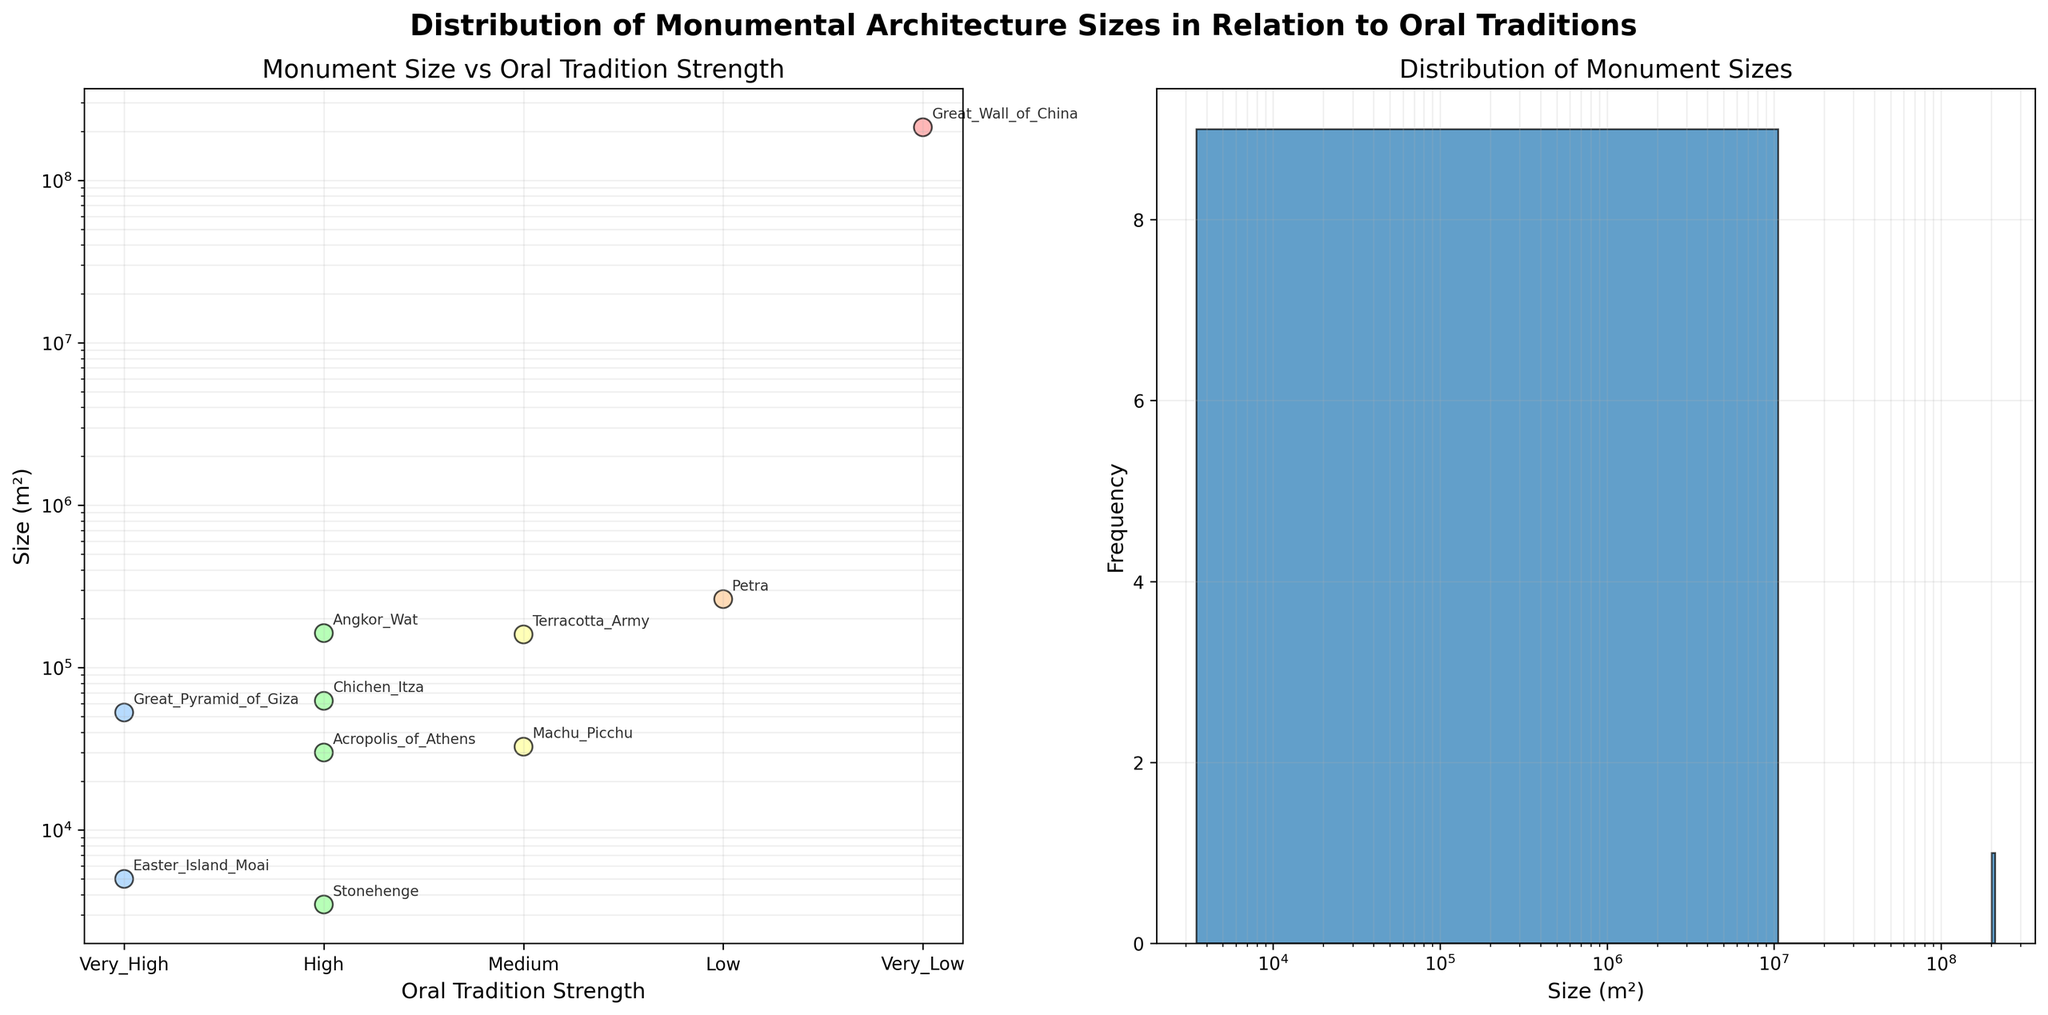Which monumental architecture has the highest size? To determine this, look at the scatter plot or the distribution histogram to identify the tallest data point on the Size axis (log scale). The highest value corresponds to the "Great Wall of China" at approximately 211,960,000 m².
Answer: Great Wall of China How many architectures are there with a 'High' oral tradition strength? In the scatter plot, observe the points colored similarly and labeled 'High'. Count these points: Stonehenge, Angkor Wat, Chichen Itza, and Acropolis of Athens, totaling 4.
Answer: 4 Which visualization shows the frequency of monument sizes? The subplot on the right shows a histogram displaying the frequency distribution of the size of monuments.
Answer: Histogram (right subplot) How does the size of Petra compare to Machu Picchu? In the scatter plot, find Petra and Machu Picchu and compare their positions on the y-axis. Petra is larger with 264,000 m², whereas Machu Picchu is 32,580 m².
Answer: Petra is larger What is the size difference between the largest and smallest monuments? Compare the Great Wall of China's size (211,960,000 m²) with Stonehenge's (3,480 m²). Calculate the difference: 211,960,000 - 3,480 = 211,956,520 m².
Answer: 211,956,520 m² Which oral tradition strength category contains the smallest monument? Look at the scatter plot, identify the monument with the smallest size, and note its corresponding oral tradition strength. Stonehenge (3,480 m²) falls under 'High'.
Answer: High What general trend can be observed between oral tradition strength and monument size? Survey the scatter plot for any patterns. Monuments with a very high oral tradition strength have smaller or moderate sizes, while sizes are more variable across other categories.
Answer: No clear strong correlation What's the total number of monumental architectures analyzed? Count the total number of data points present in both subplots (each point representing a monument). There are a total of 10 items listed.
Answer: 10 How many monumental architectures exceed 100,000 m² in size? Look at the y-axis of the scatter plot and identify points above the 100,000 m² mark. There are three: Angkor Wat, Terracotta Army, and Petra.
Answer: 3 